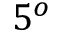Convert formula to latex. <formula><loc_0><loc_0><loc_500><loc_500>5 ^ { o }</formula> 